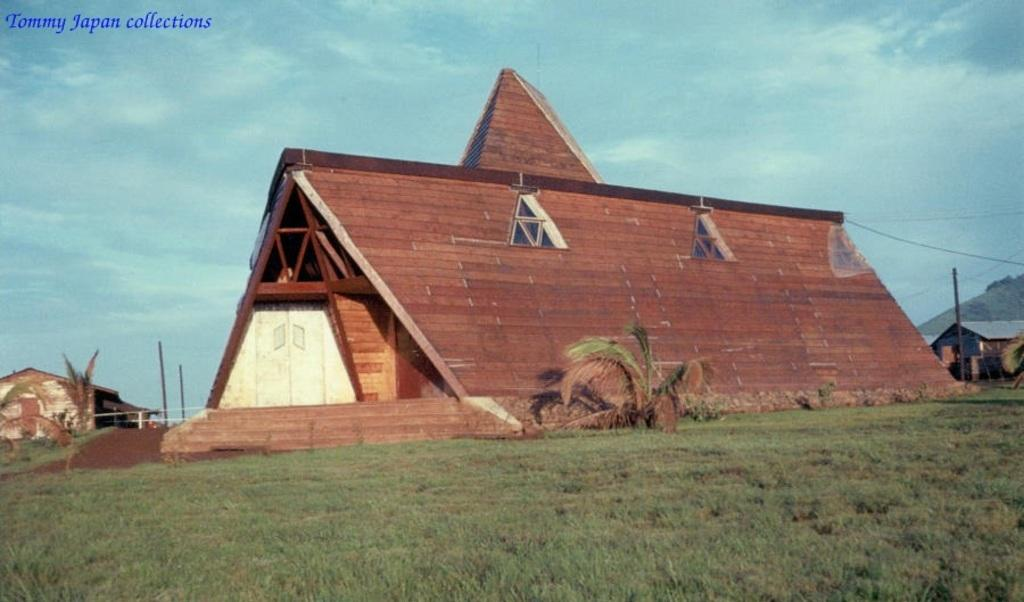What type of house is in the image? There is a wood house in the image. What architectural feature is present in the image? There are stairs in the image. What type of vegetation is visible in the image? There is grass in the image. What other living organism is present in the image? There is a plant in the image. What man-made structure is visible in the image? There is an electric pole in the image. What is connected to the electric pole in the image? There are electric wires in the image. Is there any additional marking or information on the image? There is a watermark in the image. What is the weather like in the image? The sky is cloudy in the image. What type of shop can be seen in the image? There is no shop present in the image. What size is the key used to unlock the door of the wood house in the image? There is no key visible in the image, and therefore no size can be determined. 